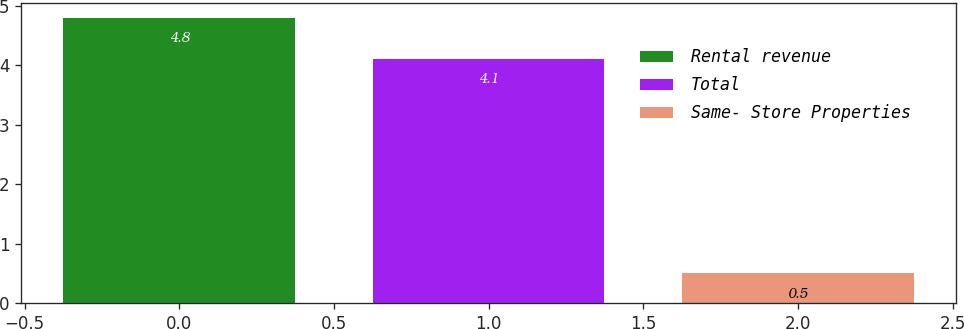<chart> <loc_0><loc_0><loc_500><loc_500><bar_chart><fcel>Rental revenue<fcel>Total<fcel>Same- Store Properties<nl><fcel>4.8<fcel>4.1<fcel>0.5<nl></chart> 